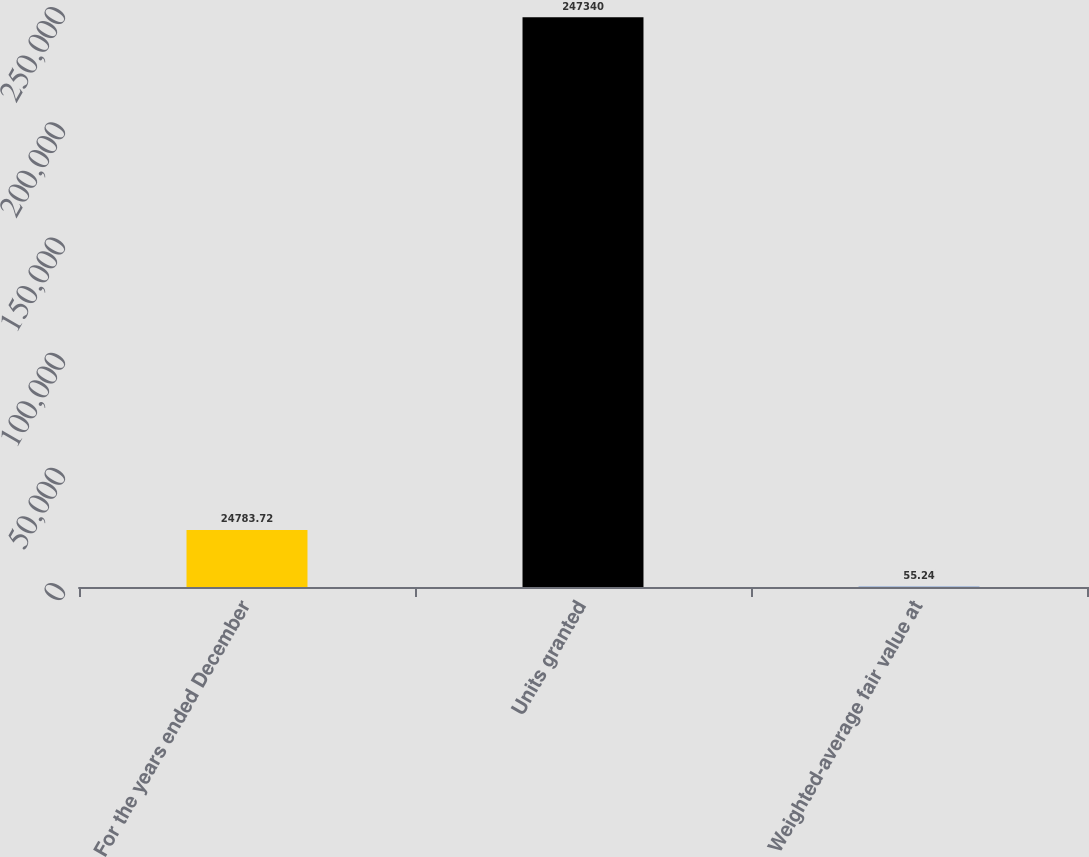<chart> <loc_0><loc_0><loc_500><loc_500><bar_chart><fcel>For the years ended December<fcel>Units granted<fcel>Weighted-average fair value at<nl><fcel>24783.7<fcel>247340<fcel>55.24<nl></chart> 